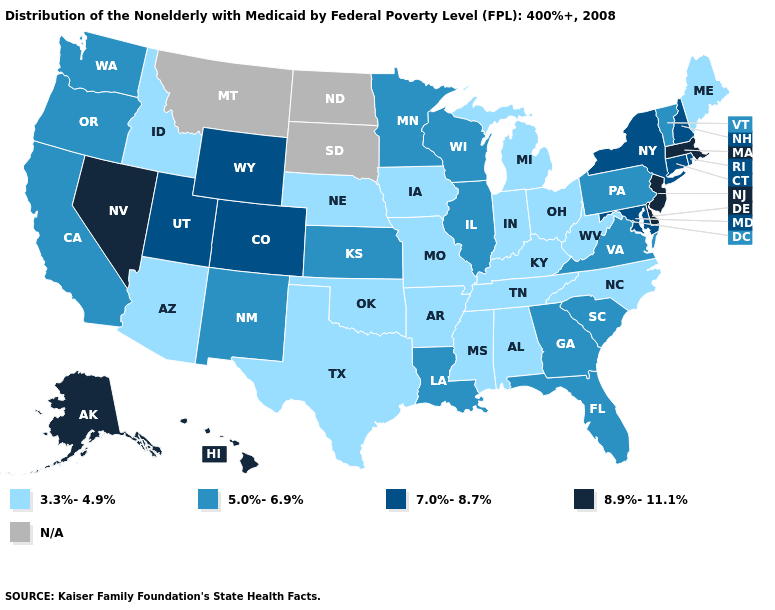What is the lowest value in the USA?
Quick response, please. 3.3%-4.9%. How many symbols are there in the legend?
Be succinct. 5. What is the value of Wisconsin?
Give a very brief answer. 5.0%-6.9%. What is the value of Colorado?
Concise answer only. 7.0%-8.7%. What is the value of Connecticut?
Write a very short answer. 7.0%-8.7%. Name the states that have a value in the range 7.0%-8.7%?
Quick response, please. Colorado, Connecticut, Maryland, New Hampshire, New York, Rhode Island, Utah, Wyoming. How many symbols are there in the legend?
Quick response, please. 5. Which states have the lowest value in the USA?
Quick response, please. Alabama, Arizona, Arkansas, Idaho, Indiana, Iowa, Kentucky, Maine, Michigan, Mississippi, Missouri, Nebraska, North Carolina, Ohio, Oklahoma, Tennessee, Texas, West Virginia. Among the states that border New York , which have the lowest value?
Keep it brief. Pennsylvania, Vermont. What is the value of Maine?
Quick response, please. 3.3%-4.9%. Among the states that border North Dakota , which have the lowest value?
Keep it brief. Minnesota. What is the value of New Hampshire?
Write a very short answer. 7.0%-8.7%. What is the value of Connecticut?
Be succinct. 7.0%-8.7%. 